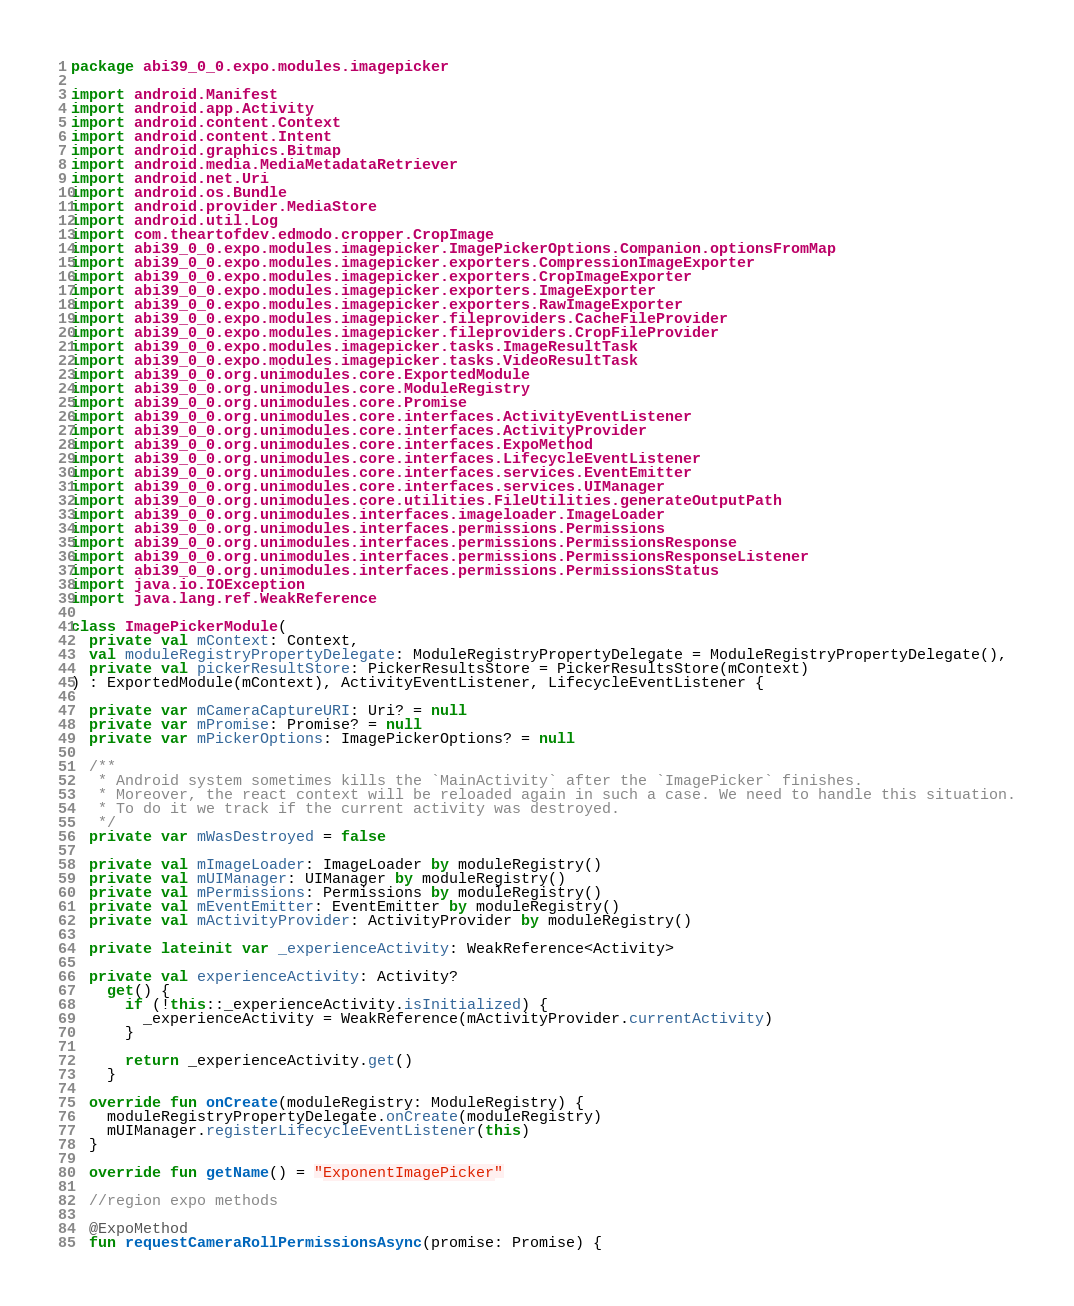Convert code to text. <code><loc_0><loc_0><loc_500><loc_500><_Kotlin_>package abi39_0_0.expo.modules.imagepicker

import android.Manifest
import android.app.Activity
import android.content.Context
import android.content.Intent
import android.graphics.Bitmap
import android.media.MediaMetadataRetriever
import android.net.Uri
import android.os.Bundle
import android.provider.MediaStore
import android.util.Log
import com.theartofdev.edmodo.cropper.CropImage
import abi39_0_0.expo.modules.imagepicker.ImagePickerOptions.Companion.optionsFromMap
import abi39_0_0.expo.modules.imagepicker.exporters.CompressionImageExporter
import abi39_0_0.expo.modules.imagepicker.exporters.CropImageExporter
import abi39_0_0.expo.modules.imagepicker.exporters.ImageExporter
import abi39_0_0.expo.modules.imagepicker.exporters.RawImageExporter
import abi39_0_0.expo.modules.imagepicker.fileproviders.CacheFileProvider
import abi39_0_0.expo.modules.imagepicker.fileproviders.CropFileProvider
import abi39_0_0.expo.modules.imagepicker.tasks.ImageResultTask
import abi39_0_0.expo.modules.imagepicker.tasks.VideoResultTask
import abi39_0_0.org.unimodules.core.ExportedModule
import abi39_0_0.org.unimodules.core.ModuleRegistry
import abi39_0_0.org.unimodules.core.Promise
import abi39_0_0.org.unimodules.core.interfaces.ActivityEventListener
import abi39_0_0.org.unimodules.core.interfaces.ActivityProvider
import abi39_0_0.org.unimodules.core.interfaces.ExpoMethod
import abi39_0_0.org.unimodules.core.interfaces.LifecycleEventListener
import abi39_0_0.org.unimodules.core.interfaces.services.EventEmitter
import abi39_0_0.org.unimodules.core.interfaces.services.UIManager
import abi39_0_0.org.unimodules.core.utilities.FileUtilities.generateOutputPath
import abi39_0_0.org.unimodules.interfaces.imageloader.ImageLoader
import abi39_0_0.org.unimodules.interfaces.permissions.Permissions
import abi39_0_0.org.unimodules.interfaces.permissions.PermissionsResponse
import abi39_0_0.org.unimodules.interfaces.permissions.PermissionsResponseListener
import abi39_0_0.org.unimodules.interfaces.permissions.PermissionsStatus
import java.io.IOException
import java.lang.ref.WeakReference

class ImagePickerModule(
  private val mContext: Context,
  val moduleRegistryPropertyDelegate: ModuleRegistryPropertyDelegate = ModuleRegistryPropertyDelegate(),
  private val pickerResultStore: PickerResultsStore = PickerResultsStore(mContext)
) : ExportedModule(mContext), ActivityEventListener, LifecycleEventListener {

  private var mCameraCaptureURI: Uri? = null
  private var mPromise: Promise? = null
  private var mPickerOptions: ImagePickerOptions? = null

  /**
   * Android system sometimes kills the `MainActivity` after the `ImagePicker` finishes.
   * Moreover, the react context will be reloaded again in such a case. We need to handle this situation.
   * To do it we track if the current activity was destroyed.
   */
  private var mWasDestroyed = false

  private val mImageLoader: ImageLoader by moduleRegistry()
  private val mUIManager: UIManager by moduleRegistry()
  private val mPermissions: Permissions by moduleRegistry()
  private val mEventEmitter: EventEmitter by moduleRegistry()
  private val mActivityProvider: ActivityProvider by moduleRegistry()

  private lateinit var _experienceActivity: WeakReference<Activity>

  private val experienceActivity: Activity?
    get() {
      if (!this::_experienceActivity.isInitialized) {
        _experienceActivity = WeakReference(mActivityProvider.currentActivity)
      }

      return _experienceActivity.get()
    }

  override fun onCreate(moduleRegistry: ModuleRegistry) {
    moduleRegistryPropertyDelegate.onCreate(moduleRegistry)
    mUIManager.registerLifecycleEventListener(this)
  }

  override fun getName() = "ExponentImagePicker"

  //region expo methods

  @ExpoMethod
  fun requestCameraRollPermissionsAsync(promise: Promise) {</code> 